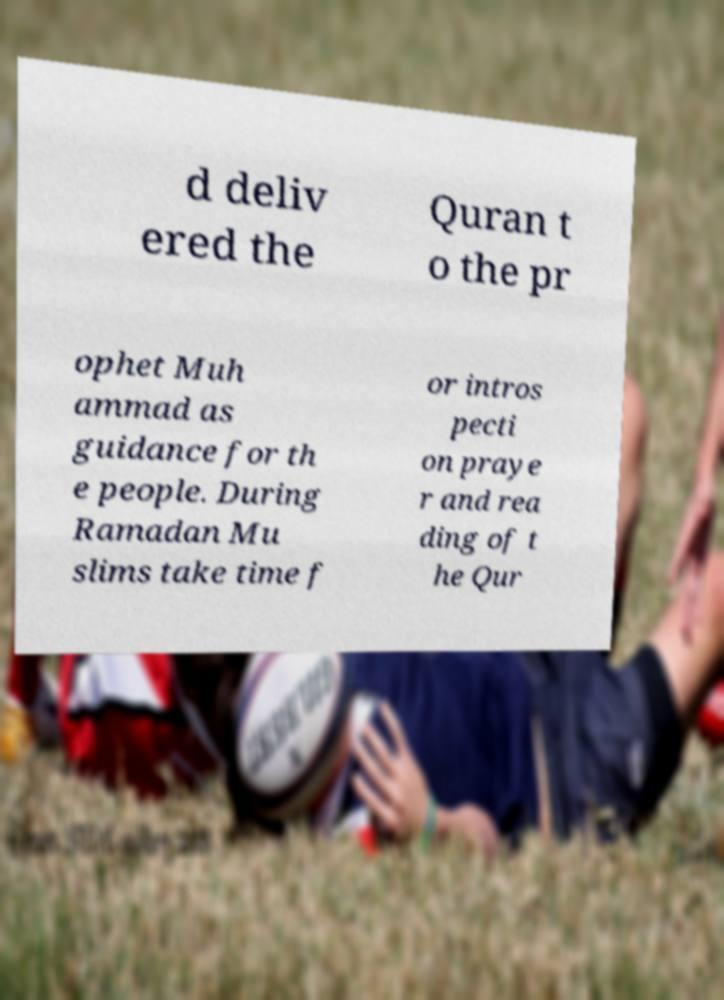Could you assist in decoding the text presented in this image and type it out clearly? d deliv ered the Quran t o the pr ophet Muh ammad as guidance for th e people. During Ramadan Mu slims take time f or intros pecti on praye r and rea ding of t he Qur 